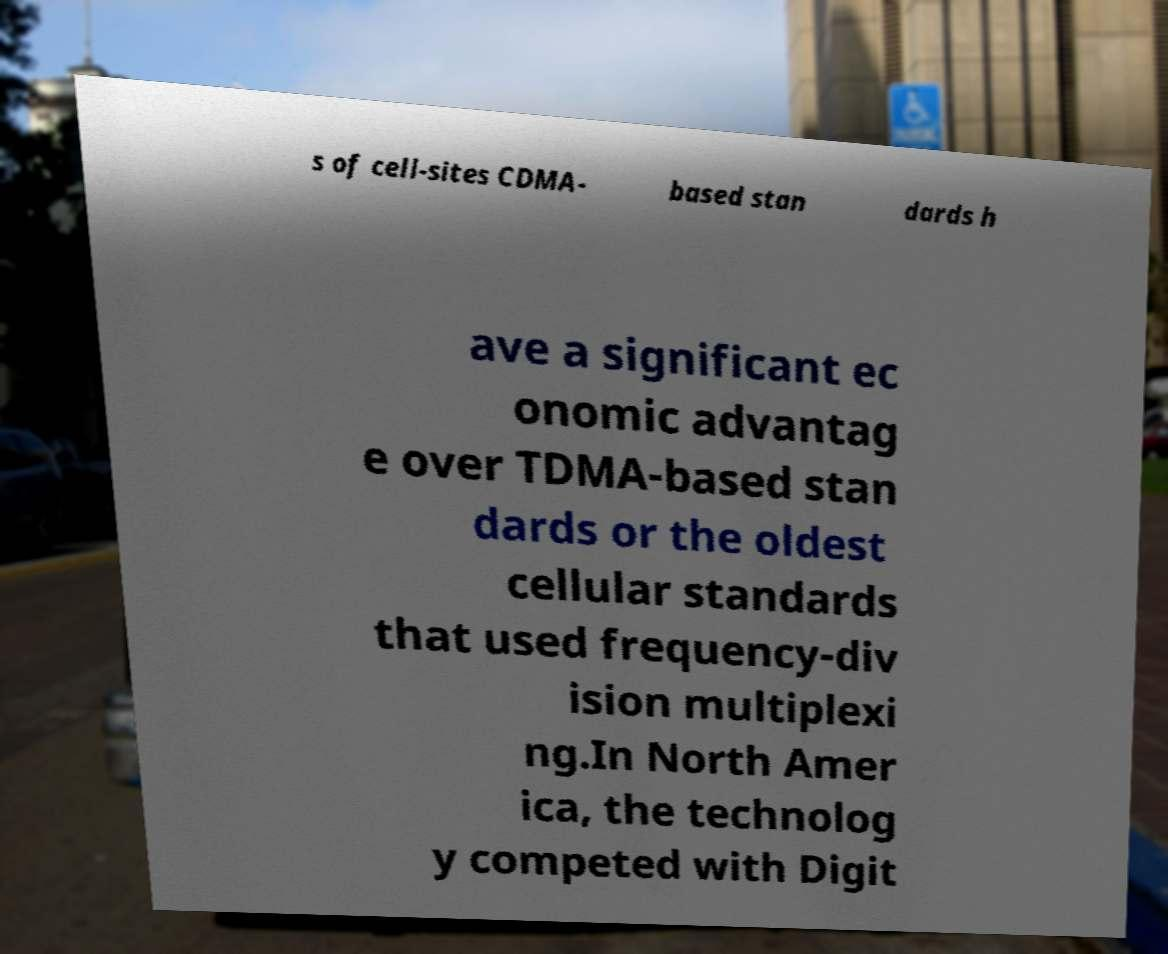Can you read and provide the text displayed in the image?This photo seems to have some interesting text. Can you extract and type it out for me? s of cell-sites CDMA- based stan dards h ave a significant ec onomic advantag e over TDMA-based stan dards or the oldest cellular standards that used frequency-div ision multiplexi ng.In North Amer ica, the technolog y competed with Digit 